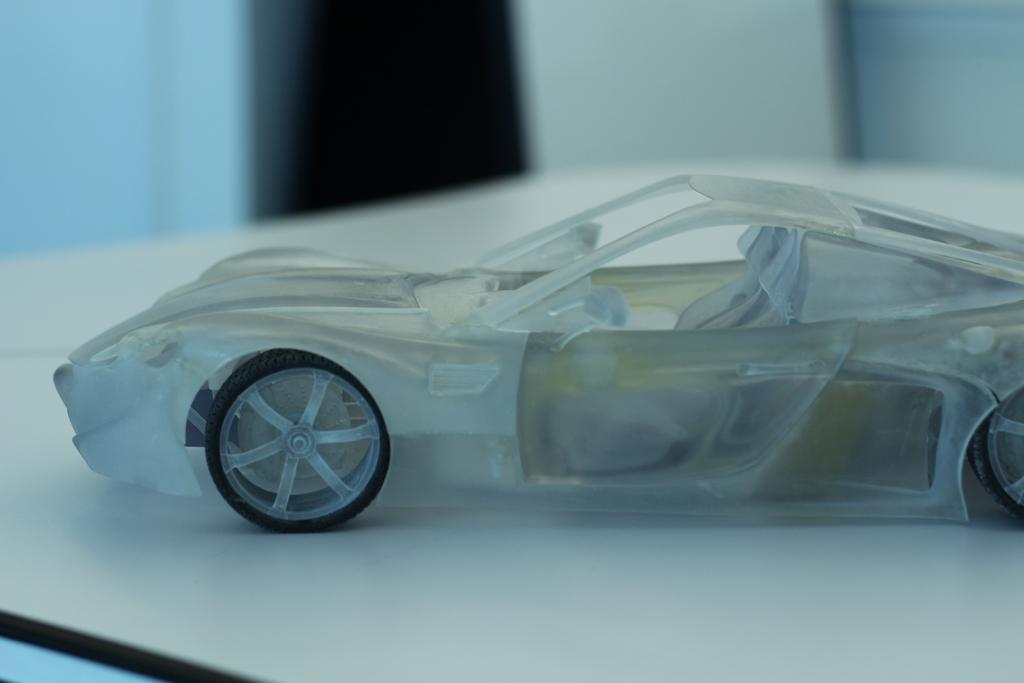What object is placed on the table in the image? There is a toy car on the table. Can you describe the background of the image? The background of the image is blurred. What type of desk is visible in the image? There is no desk present in the image. Can you tell me how many experts are featured in the image? There are no experts present in the image. 